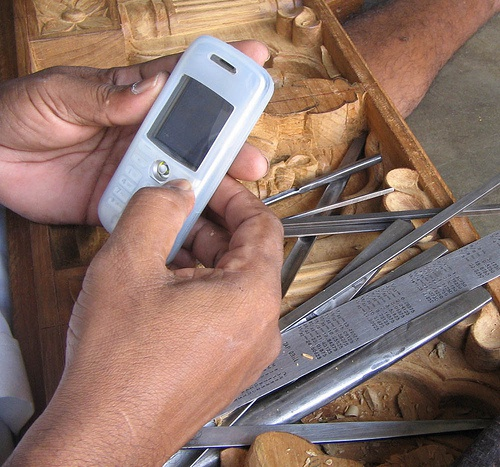Describe the objects in this image and their specific colors. I can see people in black, salmon, gray, and brown tones, cell phone in black, lavender, gray, and darkgray tones, people in black, brown, and salmon tones, knife in black and gray tones, and knife in black, gray, and darkgray tones in this image. 